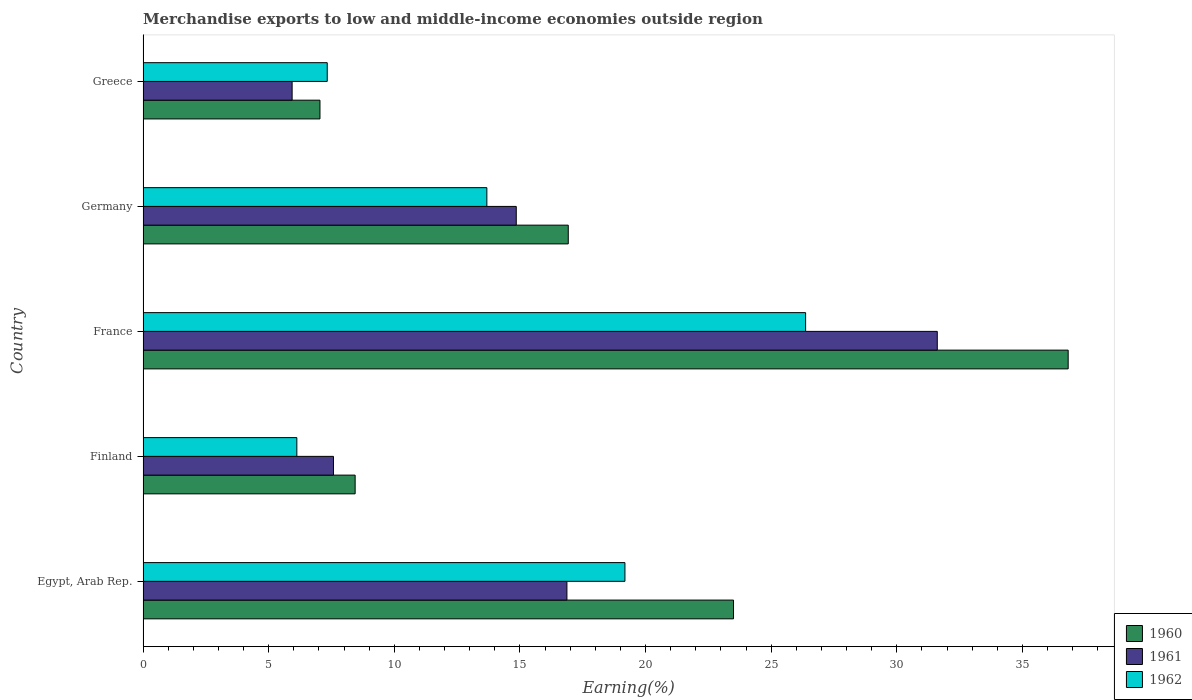How many groups of bars are there?
Your response must be concise. 5. How many bars are there on the 5th tick from the bottom?
Your answer should be compact. 3. What is the label of the 3rd group of bars from the top?
Make the answer very short. France. In how many cases, is the number of bars for a given country not equal to the number of legend labels?
Ensure brevity in your answer.  0. What is the percentage of amount earned from merchandise exports in 1962 in Finland?
Keep it short and to the point. 6.12. Across all countries, what is the maximum percentage of amount earned from merchandise exports in 1962?
Offer a very short reply. 26.37. Across all countries, what is the minimum percentage of amount earned from merchandise exports in 1960?
Provide a succinct answer. 7.04. In which country was the percentage of amount earned from merchandise exports in 1961 maximum?
Your response must be concise. France. What is the total percentage of amount earned from merchandise exports in 1962 in the graph?
Ensure brevity in your answer.  72.68. What is the difference between the percentage of amount earned from merchandise exports in 1961 in France and that in Greece?
Offer a terse response. 25.68. What is the difference between the percentage of amount earned from merchandise exports in 1962 in Greece and the percentage of amount earned from merchandise exports in 1960 in Egypt, Arab Rep.?
Keep it short and to the point. -16.17. What is the average percentage of amount earned from merchandise exports in 1960 per country?
Provide a short and direct response. 18.54. What is the difference between the percentage of amount earned from merchandise exports in 1961 and percentage of amount earned from merchandise exports in 1960 in Germany?
Your answer should be compact. -2.07. In how many countries, is the percentage of amount earned from merchandise exports in 1962 greater than 23 %?
Provide a succinct answer. 1. What is the ratio of the percentage of amount earned from merchandise exports in 1962 in Egypt, Arab Rep. to that in Germany?
Offer a terse response. 1.4. Is the difference between the percentage of amount earned from merchandise exports in 1961 in Finland and Germany greater than the difference between the percentage of amount earned from merchandise exports in 1960 in Finland and Germany?
Give a very brief answer. Yes. What is the difference between the highest and the second highest percentage of amount earned from merchandise exports in 1961?
Ensure brevity in your answer.  14.74. What is the difference between the highest and the lowest percentage of amount earned from merchandise exports in 1961?
Ensure brevity in your answer.  25.68. Are all the bars in the graph horizontal?
Your answer should be very brief. Yes. What is the difference between two consecutive major ticks on the X-axis?
Ensure brevity in your answer.  5. Does the graph contain grids?
Make the answer very short. No. Where does the legend appear in the graph?
Provide a short and direct response. Bottom right. What is the title of the graph?
Make the answer very short. Merchandise exports to low and middle-income economies outside region. Does "1974" appear as one of the legend labels in the graph?
Your answer should be very brief. No. What is the label or title of the X-axis?
Provide a succinct answer. Earning(%). What is the label or title of the Y-axis?
Keep it short and to the point. Country. What is the Earning(%) in 1960 in Egypt, Arab Rep.?
Offer a terse response. 23.5. What is the Earning(%) of 1961 in Egypt, Arab Rep.?
Keep it short and to the point. 16.87. What is the Earning(%) in 1962 in Egypt, Arab Rep.?
Ensure brevity in your answer.  19.18. What is the Earning(%) of 1960 in Finland?
Provide a succinct answer. 8.44. What is the Earning(%) of 1961 in Finland?
Keep it short and to the point. 7.58. What is the Earning(%) of 1962 in Finland?
Provide a short and direct response. 6.12. What is the Earning(%) in 1960 in France?
Offer a very short reply. 36.82. What is the Earning(%) of 1961 in France?
Your answer should be very brief. 31.61. What is the Earning(%) of 1962 in France?
Make the answer very short. 26.37. What is the Earning(%) of 1960 in Germany?
Offer a terse response. 16.92. What is the Earning(%) in 1961 in Germany?
Provide a succinct answer. 14.85. What is the Earning(%) in 1962 in Germany?
Provide a succinct answer. 13.68. What is the Earning(%) of 1960 in Greece?
Your response must be concise. 7.04. What is the Earning(%) of 1961 in Greece?
Provide a short and direct response. 5.93. What is the Earning(%) in 1962 in Greece?
Provide a short and direct response. 7.33. Across all countries, what is the maximum Earning(%) in 1960?
Provide a short and direct response. 36.82. Across all countries, what is the maximum Earning(%) of 1961?
Offer a very short reply. 31.61. Across all countries, what is the maximum Earning(%) of 1962?
Provide a succinct answer. 26.37. Across all countries, what is the minimum Earning(%) in 1960?
Provide a short and direct response. 7.04. Across all countries, what is the minimum Earning(%) of 1961?
Provide a short and direct response. 5.93. Across all countries, what is the minimum Earning(%) in 1962?
Your answer should be very brief. 6.12. What is the total Earning(%) in 1960 in the graph?
Provide a succinct answer. 92.72. What is the total Earning(%) in 1961 in the graph?
Provide a short and direct response. 76.84. What is the total Earning(%) of 1962 in the graph?
Offer a terse response. 72.68. What is the difference between the Earning(%) in 1960 in Egypt, Arab Rep. and that in Finland?
Keep it short and to the point. 15.06. What is the difference between the Earning(%) in 1961 in Egypt, Arab Rep. and that in Finland?
Offer a very short reply. 9.29. What is the difference between the Earning(%) of 1962 in Egypt, Arab Rep. and that in Finland?
Offer a terse response. 13.06. What is the difference between the Earning(%) of 1960 in Egypt, Arab Rep. and that in France?
Ensure brevity in your answer.  -13.32. What is the difference between the Earning(%) of 1961 in Egypt, Arab Rep. and that in France?
Provide a short and direct response. -14.74. What is the difference between the Earning(%) in 1962 in Egypt, Arab Rep. and that in France?
Your response must be concise. -7.19. What is the difference between the Earning(%) of 1960 in Egypt, Arab Rep. and that in Germany?
Provide a succinct answer. 6.58. What is the difference between the Earning(%) in 1961 in Egypt, Arab Rep. and that in Germany?
Offer a very short reply. 2.02. What is the difference between the Earning(%) in 1962 in Egypt, Arab Rep. and that in Germany?
Your response must be concise. 5.5. What is the difference between the Earning(%) of 1960 in Egypt, Arab Rep. and that in Greece?
Give a very brief answer. 16.46. What is the difference between the Earning(%) of 1961 in Egypt, Arab Rep. and that in Greece?
Provide a short and direct response. 10.94. What is the difference between the Earning(%) in 1962 in Egypt, Arab Rep. and that in Greece?
Make the answer very short. 11.85. What is the difference between the Earning(%) in 1960 in Finland and that in France?
Offer a terse response. -28.38. What is the difference between the Earning(%) in 1961 in Finland and that in France?
Offer a terse response. -24.03. What is the difference between the Earning(%) in 1962 in Finland and that in France?
Offer a very short reply. -20.25. What is the difference between the Earning(%) in 1960 in Finland and that in Germany?
Offer a very short reply. -8.48. What is the difference between the Earning(%) in 1961 in Finland and that in Germany?
Keep it short and to the point. -7.28. What is the difference between the Earning(%) in 1962 in Finland and that in Germany?
Keep it short and to the point. -7.56. What is the difference between the Earning(%) in 1960 in Finland and that in Greece?
Make the answer very short. 1.4. What is the difference between the Earning(%) of 1961 in Finland and that in Greece?
Offer a very short reply. 1.65. What is the difference between the Earning(%) of 1962 in Finland and that in Greece?
Provide a short and direct response. -1.21. What is the difference between the Earning(%) in 1960 in France and that in Germany?
Offer a very short reply. 19.9. What is the difference between the Earning(%) in 1961 in France and that in Germany?
Your response must be concise. 16.76. What is the difference between the Earning(%) in 1962 in France and that in Germany?
Your answer should be very brief. 12.69. What is the difference between the Earning(%) of 1960 in France and that in Greece?
Give a very brief answer. 29.78. What is the difference between the Earning(%) of 1961 in France and that in Greece?
Your answer should be compact. 25.68. What is the difference between the Earning(%) in 1962 in France and that in Greece?
Offer a very short reply. 19.04. What is the difference between the Earning(%) in 1960 in Germany and that in Greece?
Keep it short and to the point. 9.88. What is the difference between the Earning(%) in 1961 in Germany and that in Greece?
Provide a succinct answer. 8.92. What is the difference between the Earning(%) in 1962 in Germany and that in Greece?
Ensure brevity in your answer.  6.35. What is the difference between the Earning(%) of 1960 in Egypt, Arab Rep. and the Earning(%) of 1961 in Finland?
Make the answer very short. 15.92. What is the difference between the Earning(%) in 1960 in Egypt, Arab Rep. and the Earning(%) in 1962 in Finland?
Make the answer very short. 17.38. What is the difference between the Earning(%) in 1961 in Egypt, Arab Rep. and the Earning(%) in 1962 in Finland?
Your answer should be compact. 10.75. What is the difference between the Earning(%) of 1960 in Egypt, Arab Rep. and the Earning(%) of 1961 in France?
Provide a short and direct response. -8.11. What is the difference between the Earning(%) of 1960 in Egypt, Arab Rep. and the Earning(%) of 1962 in France?
Offer a terse response. -2.87. What is the difference between the Earning(%) of 1961 in Egypt, Arab Rep. and the Earning(%) of 1962 in France?
Offer a terse response. -9.5. What is the difference between the Earning(%) in 1960 in Egypt, Arab Rep. and the Earning(%) in 1961 in Germany?
Ensure brevity in your answer.  8.65. What is the difference between the Earning(%) in 1960 in Egypt, Arab Rep. and the Earning(%) in 1962 in Germany?
Give a very brief answer. 9.82. What is the difference between the Earning(%) in 1961 in Egypt, Arab Rep. and the Earning(%) in 1962 in Germany?
Give a very brief answer. 3.19. What is the difference between the Earning(%) of 1960 in Egypt, Arab Rep. and the Earning(%) of 1961 in Greece?
Make the answer very short. 17.57. What is the difference between the Earning(%) of 1960 in Egypt, Arab Rep. and the Earning(%) of 1962 in Greece?
Offer a terse response. 16.17. What is the difference between the Earning(%) of 1961 in Egypt, Arab Rep. and the Earning(%) of 1962 in Greece?
Provide a short and direct response. 9.54. What is the difference between the Earning(%) of 1960 in Finland and the Earning(%) of 1961 in France?
Offer a very short reply. -23.17. What is the difference between the Earning(%) in 1960 in Finland and the Earning(%) in 1962 in France?
Keep it short and to the point. -17.93. What is the difference between the Earning(%) of 1961 in Finland and the Earning(%) of 1962 in France?
Your answer should be compact. -18.79. What is the difference between the Earning(%) in 1960 in Finland and the Earning(%) in 1961 in Germany?
Make the answer very short. -6.41. What is the difference between the Earning(%) of 1960 in Finland and the Earning(%) of 1962 in Germany?
Make the answer very short. -5.24. What is the difference between the Earning(%) in 1961 in Finland and the Earning(%) in 1962 in Germany?
Provide a short and direct response. -6.11. What is the difference between the Earning(%) of 1960 in Finland and the Earning(%) of 1961 in Greece?
Keep it short and to the point. 2.51. What is the difference between the Earning(%) of 1960 in Finland and the Earning(%) of 1962 in Greece?
Provide a short and direct response. 1.11. What is the difference between the Earning(%) in 1961 in Finland and the Earning(%) in 1962 in Greece?
Your response must be concise. 0.25. What is the difference between the Earning(%) of 1960 in France and the Earning(%) of 1961 in Germany?
Your answer should be very brief. 21.97. What is the difference between the Earning(%) of 1960 in France and the Earning(%) of 1962 in Germany?
Offer a very short reply. 23.14. What is the difference between the Earning(%) in 1961 in France and the Earning(%) in 1962 in Germany?
Keep it short and to the point. 17.93. What is the difference between the Earning(%) in 1960 in France and the Earning(%) in 1961 in Greece?
Your answer should be very brief. 30.89. What is the difference between the Earning(%) of 1960 in France and the Earning(%) of 1962 in Greece?
Make the answer very short. 29.49. What is the difference between the Earning(%) of 1961 in France and the Earning(%) of 1962 in Greece?
Offer a very short reply. 24.28. What is the difference between the Earning(%) in 1960 in Germany and the Earning(%) in 1961 in Greece?
Give a very brief answer. 10.99. What is the difference between the Earning(%) of 1960 in Germany and the Earning(%) of 1962 in Greece?
Make the answer very short. 9.59. What is the difference between the Earning(%) in 1961 in Germany and the Earning(%) in 1962 in Greece?
Keep it short and to the point. 7.52. What is the average Earning(%) in 1960 per country?
Your answer should be compact. 18.54. What is the average Earning(%) in 1961 per country?
Provide a short and direct response. 15.37. What is the average Earning(%) of 1962 per country?
Provide a succinct answer. 14.54. What is the difference between the Earning(%) of 1960 and Earning(%) of 1961 in Egypt, Arab Rep.?
Your answer should be compact. 6.63. What is the difference between the Earning(%) in 1960 and Earning(%) in 1962 in Egypt, Arab Rep.?
Your answer should be compact. 4.32. What is the difference between the Earning(%) of 1961 and Earning(%) of 1962 in Egypt, Arab Rep.?
Your response must be concise. -2.31. What is the difference between the Earning(%) of 1960 and Earning(%) of 1961 in Finland?
Ensure brevity in your answer.  0.86. What is the difference between the Earning(%) of 1960 and Earning(%) of 1962 in Finland?
Your answer should be very brief. 2.32. What is the difference between the Earning(%) in 1961 and Earning(%) in 1962 in Finland?
Offer a very short reply. 1.46. What is the difference between the Earning(%) of 1960 and Earning(%) of 1961 in France?
Your answer should be compact. 5.21. What is the difference between the Earning(%) in 1960 and Earning(%) in 1962 in France?
Ensure brevity in your answer.  10.45. What is the difference between the Earning(%) in 1961 and Earning(%) in 1962 in France?
Give a very brief answer. 5.24. What is the difference between the Earning(%) of 1960 and Earning(%) of 1961 in Germany?
Give a very brief answer. 2.07. What is the difference between the Earning(%) in 1960 and Earning(%) in 1962 in Germany?
Provide a succinct answer. 3.24. What is the difference between the Earning(%) of 1961 and Earning(%) of 1962 in Germany?
Ensure brevity in your answer.  1.17. What is the difference between the Earning(%) in 1960 and Earning(%) in 1961 in Greece?
Keep it short and to the point. 1.11. What is the difference between the Earning(%) of 1960 and Earning(%) of 1962 in Greece?
Your answer should be compact. -0.29. What is the difference between the Earning(%) in 1961 and Earning(%) in 1962 in Greece?
Ensure brevity in your answer.  -1.4. What is the ratio of the Earning(%) of 1960 in Egypt, Arab Rep. to that in Finland?
Make the answer very short. 2.78. What is the ratio of the Earning(%) in 1961 in Egypt, Arab Rep. to that in Finland?
Provide a succinct answer. 2.23. What is the ratio of the Earning(%) of 1962 in Egypt, Arab Rep. to that in Finland?
Your answer should be compact. 3.13. What is the ratio of the Earning(%) in 1960 in Egypt, Arab Rep. to that in France?
Make the answer very short. 0.64. What is the ratio of the Earning(%) in 1961 in Egypt, Arab Rep. to that in France?
Give a very brief answer. 0.53. What is the ratio of the Earning(%) of 1962 in Egypt, Arab Rep. to that in France?
Your response must be concise. 0.73. What is the ratio of the Earning(%) in 1960 in Egypt, Arab Rep. to that in Germany?
Provide a short and direct response. 1.39. What is the ratio of the Earning(%) in 1961 in Egypt, Arab Rep. to that in Germany?
Offer a very short reply. 1.14. What is the ratio of the Earning(%) in 1962 in Egypt, Arab Rep. to that in Germany?
Your answer should be compact. 1.4. What is the ratio of the Earning(%) of 1960 in Egypt, Arab Rep. to that in Greece?
Make the answer very short. 3.34. What is the ratio of the Earning(%) in 1961 in Egypt, Arab Rep. to that in Greece?
Ensure brevity in your answer.  2.84. What is the ratio of the Earning(%) of 1962 in Egypt, Arab Rep. to that in Greece?
Keep it short and to the point. 2.62. What is the ratio of the Earning(%) of 1960 in Finland to that in France?
Your answer should be very brief. 0.23. What is the ratio of the Earning(%) in 1961 in Finland to that in France?
Your answer should be very brief. 0.24. What is the ratio of the Earning(%) of 1962 in Finland to that in France?
Your answer should be very brief. 0.23. What is the ratio of the Earning(%) of 1960 in Finland to that in Germany?
Your response must be concise. 0.5. What is the ratio of the Earning(%) of 1961 in Finland to that in Germany?
Make the answer very short. 0.51. What is the ratio of the Earning(%) in 1962 in Finland to that in Germany?
Ensure brevity in your answer.  0.45. What is the ratio of the Earning(%) of 1960 in Finland to that in Greece?
Make the answer very short. 1.2. What is the ratio of the Earning(%) in 1961 in Finland to that in Greece?
Give a very brief answer. 1.28. What is the ratio of the Earning(%) in 1962 in Finland to that in Greece?
Give a very brief answer. 0.83. What is the ratio of the Earning(%) of 1960 in France to that in Germany?
Your response must be concise. 2.18. What is the ratio of the Earning(%) in 1961 in France to that in Germany?
Offer a very short reply. 2.13. What is the ratio of the Earning(%) in 1962 in France to that in Germany?
Your answer should be compact. 1.93. What is the ratio of the Earning(%) of 1960 in France to that in Greece?
Keep it short and to the point. 5.23. What is the ratio of the Earning(%) in 1961 in France to that in Greece?
Offer a terse response. 5.33. What is the ratio of the Earning(%) in 1962 in France to that in Greece?
Give a very brief answer. 3.6. What is the ratio of the Earning(%) of 1960 in Germany to that in Greece?
Offer a very short reply. 2.4. What is the ratio of the Earning(%) in 1961 in Germany to that in Greece?
Provide a short and direct response. 2.5. What is the ratio of the Earning(%) of 1962 in Germany to that in Greece?
Offer a terse response. 1.87. What is the difference between the highest and the second highest Earning(%) in 1960?
Keep it short and to the point. 13.32. What is the difference between the highest and the second highest Earning(%) of 1961?
Provide a succinct answer. 14.74. What is the difference between the highest and the second highest Earning(%) of 1962?
Offer a terse response. 7.19. What is the difference between the highest and the lowest Earning(%) of 1960?
Give a very brief answer. 29.78. What is the difference between the highest and the lowest Earning(%) of 1961?
Keep it short and to the point. 25.68. What is the difference between the highest and the lowest Earning(%) in 1962?
Ensure brevity in your answer.  20.25. 